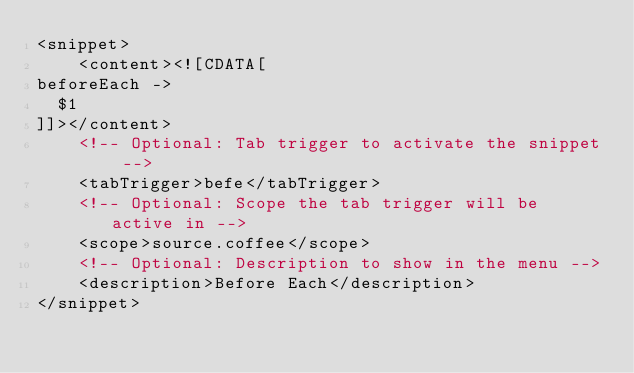<code> <loc_0><loc_0><loc_500><loc_500><_XML_><snippet>
    <content><![CDATA[
beforeEach ->
	$1
]]></content>
    <!-- Optional: Tab trigger to activate the snippet -->
    <tabTrigger>befe</tabTrigger>
    <!-- Optional: Scope the tab trigger will be active in -->
    <scope>source.coffee</scope>
    <!-- Optional: Description to show in the menu -->
    <description>Before Each</description>
</snippet></code> 